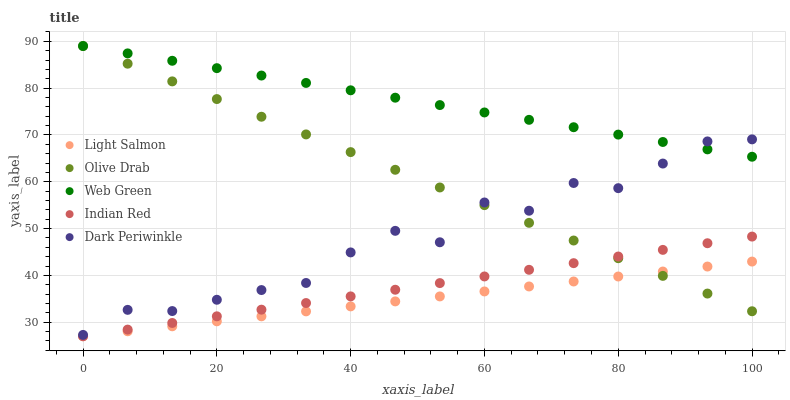Does Light Salmon have the minimum area under the curve?
Answer yes or no. Yes. Does Web Green have the maximum area under the curve?
Answer yes or no. Yes. Does Web Green have the minimum area under the curve?
Answer yes or no. No. Does Light Salmon have the maximum area under the curve?
Answer yes or no. No. Is Indian Red the smoothest?
Answer yes or no. Yes. Is Dark Periwinkle the roughest?
Answer yes or no. Yes. Is Light Salmon the smoothest?
Answer yes or no. No. Is Light Salmon the roughest?
Answer yes or no. No. Does Indian Red have the lowest value?
Answer yes or no. Yes. Does Web Green have the lowest value?
Answer yes or no. No. Does Olive Drab have the highest value?
Answer yes or no. Yes. Does Light Salmon have the highest value?
Answer yes or no. No. Is Light Salmon less than Web Green?
Answer yes or no. Yes. Is Dark Periwinkle greater than Light Salmon?
Answer yes or no. Yes. Does Indian Red intersect Olive Drab?
Answer yes or no. Yes. Is Indian Red less than Olive Drab?
Answer yes or no. No. Is Indian Red greater than Olive Drab?
Answer yes or no. No. Does Light Salmon intersect Web Green?
Answer yes or no. No. 